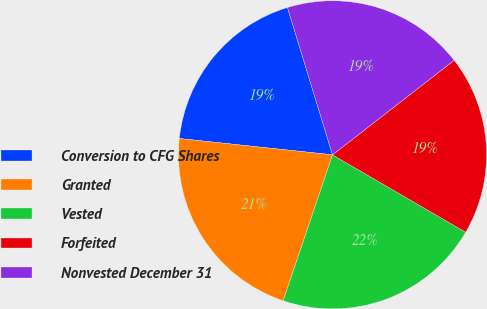Convert chart to OTSL. <chart><loc_0><loc_0><loc_500><loc_500><pie_chart><fcel>Conversion to CFG Shares<fcel>Granted<fcel>Vested<fcel>Forfeited<fcel>Nonvested December 31<nl><fcel>18.59%<fcel>21.5%<fcel>21.81%<fcel>18.9%<fcel>19.21%<nl></chart> 